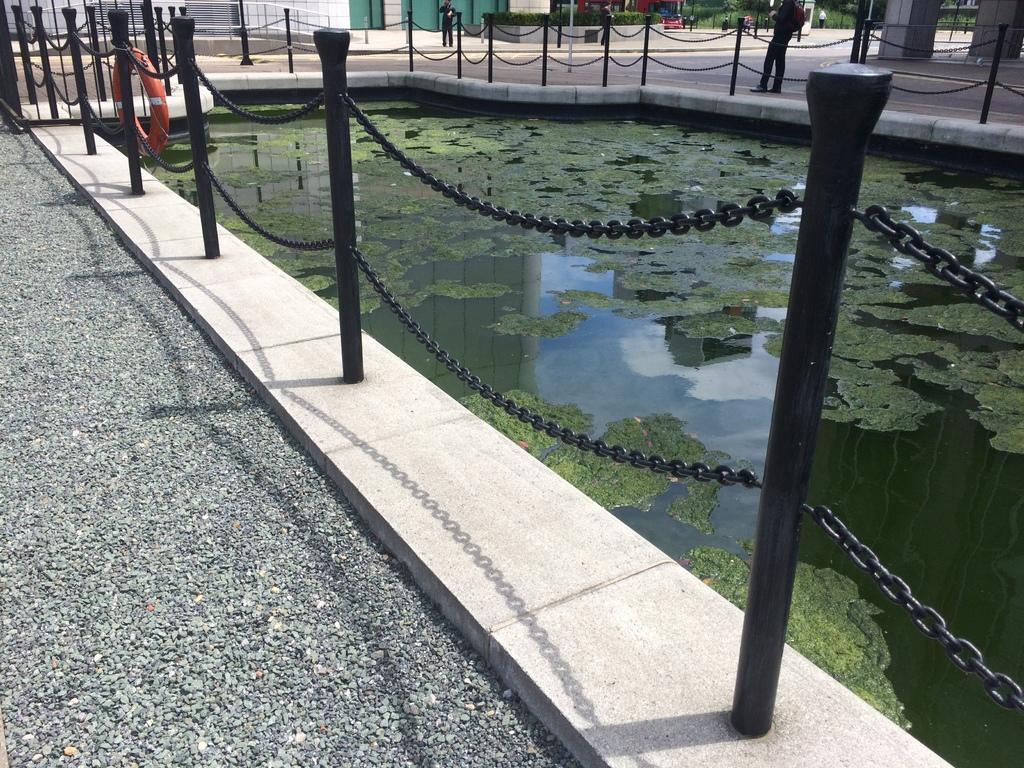What type of surface is visible in the image? There is a pavement in the image. What body of water is present in the image? There is a pond in the image. What feature surrounds the pond? There is a railing around the pond. Can you describe the people in the image? The people are standing in the background of the image. What type of quill can be seen in the image? There is no quill present in the image. What is located at the front of the pond in the image? The image does not show a specific front or back of the pond, as it is a two-dimensional representation. 